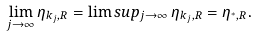Convert formula to latex. <formula><loc_0><loc_0><loc_500><loc_500>\lim _ { j \to \infty } \eta _ { k _ { j } , R } = \lim s u p _ { j \to \infty } \, \eta _ { k _ { j } , R } = \eta _ { ^ { * } , R } .</formula> 